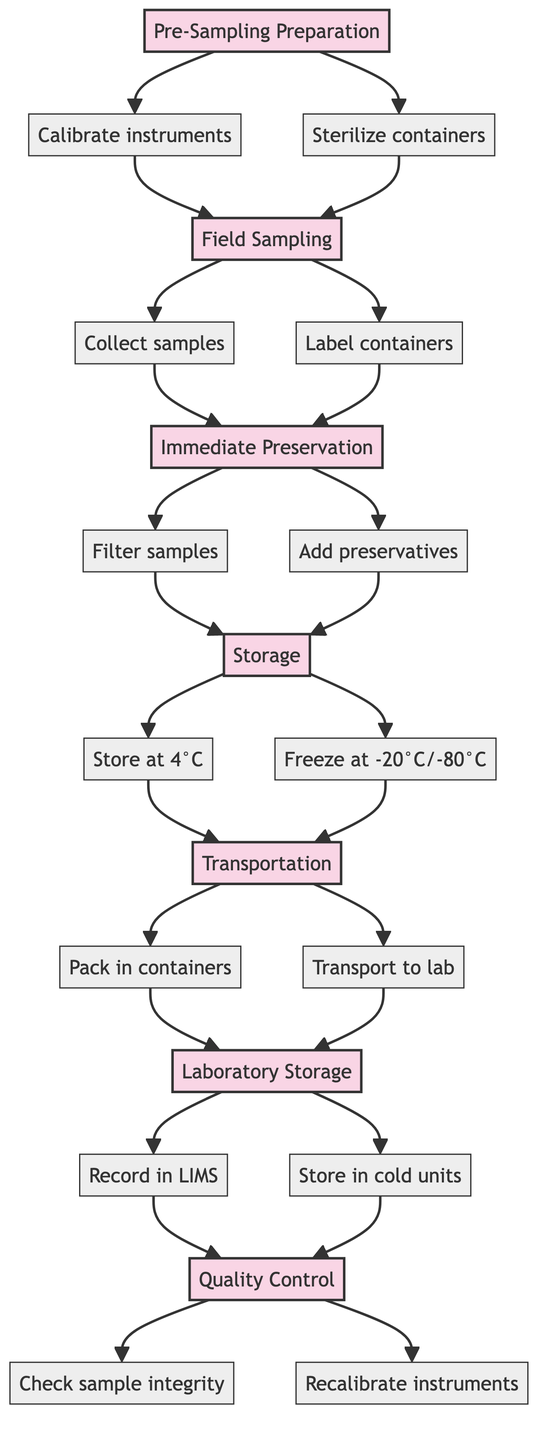What is the first step in the process? The diagram shows that the first step in the process is "Pre-Sampling Preparation."
Answer: Pre-Sampling Preparation How many actions are listed under "Immediate Preservation"? Under "Immediate Preservation," there are two actions: "Filter samples using 0.2 µm membrane filters to remove particulates" and "Add preservatives." Therefore, the total is two actions.
Answer: 2 What happens immediately after "Field Sampling"? After "Field Sampling," the process moves to "Immediate Preservation," which is the next step indicated in the diagram.
Answer: Immediate Preservation What are the storage temperature options listed in the "Storage" step? The "Storage" step lists two temperature options: "Store samples at 4°C for short-term analysis" and "Freeze samples at -20°C or -80°C for long-term storage."
Answer: 4°C, -20°C or -80°C Which step follows "Transportation"? According to the flow chart, the step that follows "Transportation" is "Laboratory Storage."
Answer: Laboratory Storage How many quality control actions are defined in the flowchart? The "Quality Control" step includes two actions: "Perform regular checks on sample integrity" and "Recalibrate instruments before final analysis." Thus, there are two quality control actions defined.
Answer: 2 What indicates that quality control is the final step in the process? The diagram shows that "Quality Control" is the last step and has no outgoing arrows leading to other steps, indicating that it is the end of the process flow.
Answer: Quality Control Which step contains the action to add preservatives? The action to "Add preservatives" is found under the "Immediate Preservation" step of the process.
Answer: Immediate Preservation What is the primary goal of "Field Sampling"? The primary goals of "Field Sampling" are to "Collect seawater samples using Niskin bottles" and to "Label containers with sample identifiers and GPS coordinates." Therefore, the focus is on sample collection and proper labeling.
Answer: Collect seawater samples, label containers 